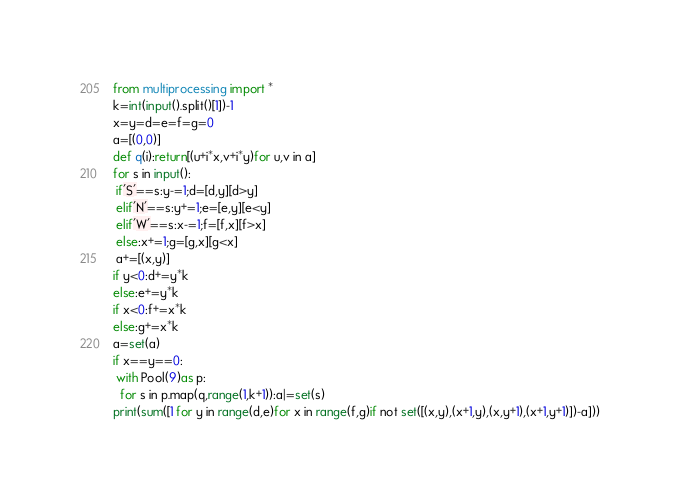<code> <loc_0><loc_0><loc_500><loc_500><_Python_>from multiprocessing import *
k=int(input().split()[1])-1
x=y=d=e=f=g=0
a=[(0,0)]
def q(i):return[(u+i*x,v+i*y)for u,v in a]
for s in input():
 if'S'==s:y-=1;d=[d,y][d>y]
 elif'N'==s:y+=1;e=[e,y][e<y]
 elif'W'==s:x-=1;f=[f,x][f>x]
 else:x+=1;g=[g,x][g<x]
 a+=[(x,y)]
if y<0:d+=y*k
else:e+=y*k
if x<0:f+=x*k
else:g+=x*k
a=set(a)
if x==y==0:
 with Pool(9)as p:
  for s in p.map(q,range(1,k+1)):a|=set(s)
print(sum([1 for y in range(d,e)for x in range(f,g)if not set([(x,y),(x+1,y),(x,y+1),(x+1,y+1)])-a]))
</code> 